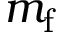<formula> <loc_0><loc_0><loc_500><loc_500>m _ { f }</formula> 